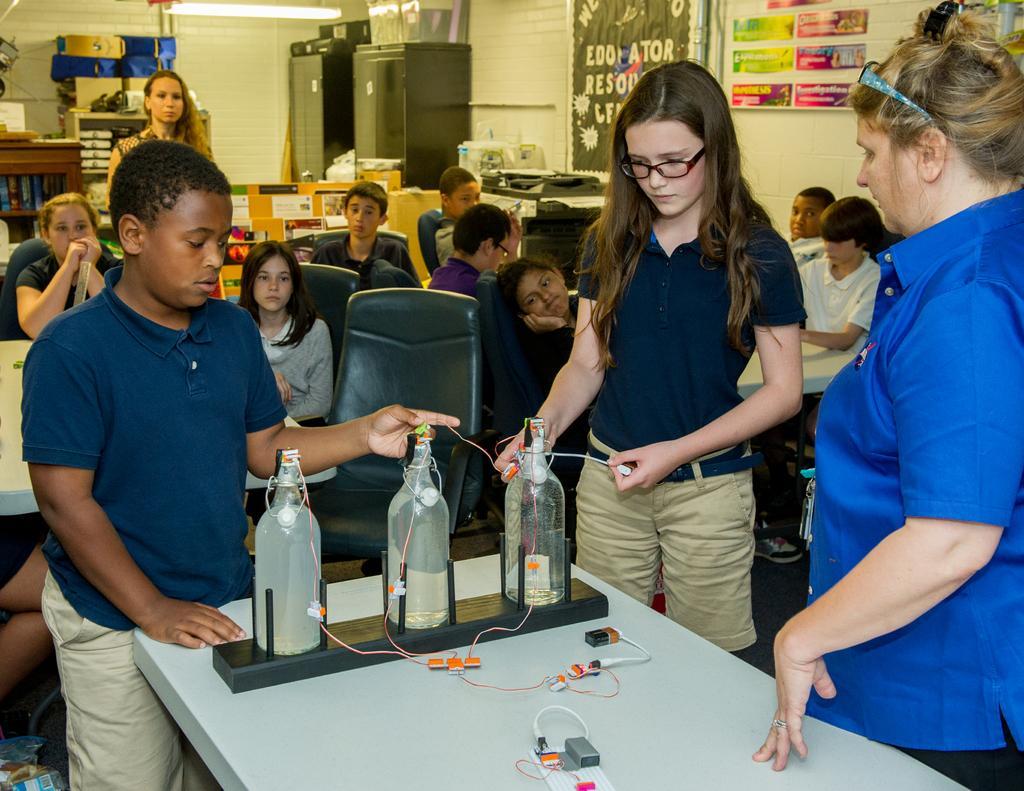Could you give a brief overview of what you see in this image? In this picture there are some students who are sitting and some of them are standing there showing their experiment 